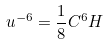Convert formula to latex. <formula><loc_0><loc_0><loc_500><loc_500>u ^ { - 6 } = { \frac { 1 } { 8 } } C ^ { 6 } H</formula> 